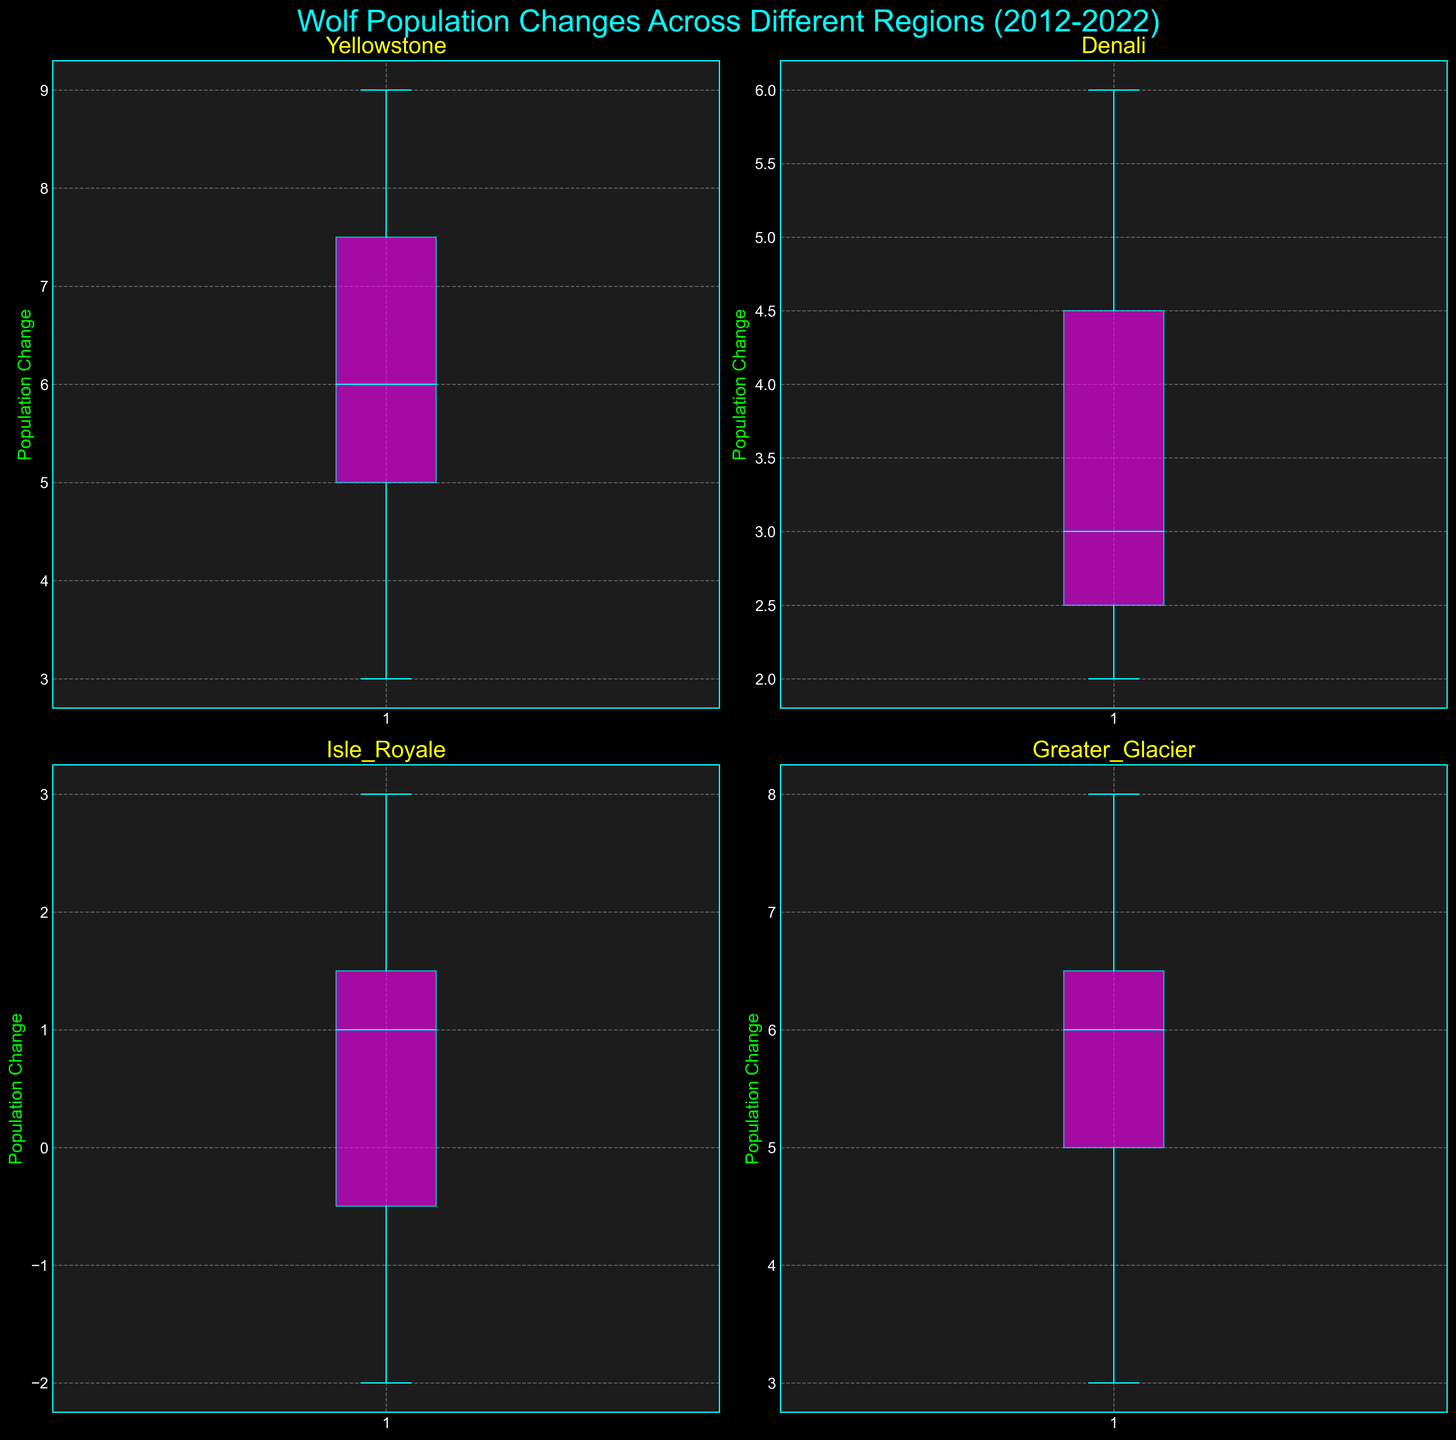What's the title of the figure? The title of the figure is displayed at the top center in a large cyan color font.
Answer: Wolf Population Changes Across Different Regions (2012-2022) What color are the whiskers and boxes in the box plots? Observing the figure, the whiskers and boxes are colored cyan.
Answer: cyan In terms of median wolf population change, which region shows the highest value? By looking at the central line in each box plot (representing the median), we see the highest median line in the Greater Glacier subplot.
Answer: Greater Glacier How many regions' wolf population changes are plotted? There are four subplots each representing different regions, thus plotting wolf population changes for four regions.
Answer: 4 Which region has the most consistent wolf population change (least variability)? Consistent change means less variability, which can be inferred from the shortest interquartile range (IQR) or box height. Denali’s box plot has the shortest IQR.
Answer: Denali What is the median population change in Yellowstone? The median value is represented by the line in the middle of the Yellowstone box plot. For Yellowstone, this value is 6.
Answer: 6 Comparing Yellowstone and Isle Royale, which region has a higher maximum wolf population change? Check the highest point (upper whisker) of the box plots. Yellowstone's maximum value is higher than that of Isle Royale.
Answer: Yellowstone Which region has the lowest minimum value for wolf population change? Identify the lowest point (lower whisker) across all subplots. Isle Royale has the lowest minimum value of -2.
Answer: Isle Royale Is the median wolf population change in Yellowstone greater than in Denali? Look at the central lines of the two box plots. Yellowstone’s median line is higher than Denali’s.
Answer: Yes Does Greater Glacier show an increase or decrease in its average wolf population change over the years? The box plot for Greater Glacier has both higher median and overall values compared to others. This suggests that the average has increased.
Answer: Increase 